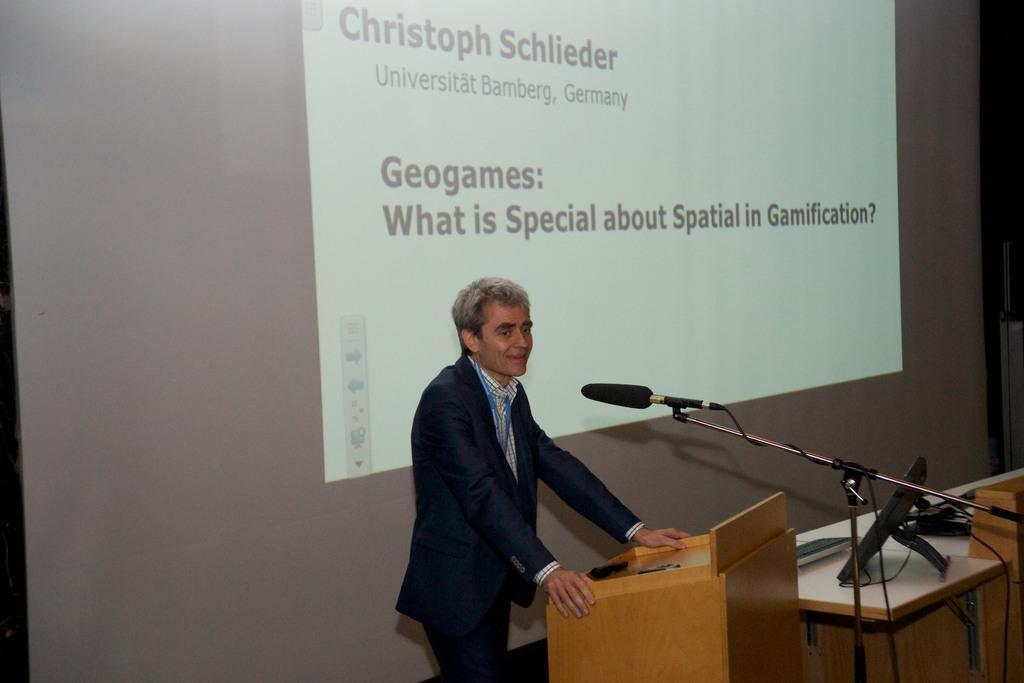Who or what is the main subject in the image? There is a person in the image. What is the person standing in front of? The person is standing in front of a wooden table. What object is in front of the person? There is a mic in front of the person. What can be seen behind the person? There is a projected image behind the person. What type of dinosaurs are visible in the projected image? There are no dinosaurs visible in the projected image; it contains something else. 